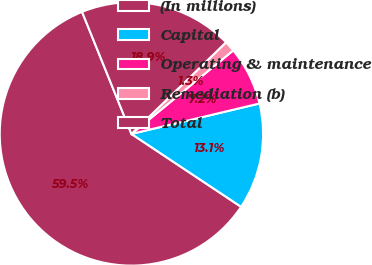Convert chart to OTSL. <chart><loc_0><loc_0><loc_500><loc_500><pie_chart><fcel>(In millions)<fcel>Capital<fcel>Operating & maintenance<fcel>Remediation (b)<fcel>Total<nl><fcel>59.55%<fcel>13.05%<fcel>7.22%<fcel>1.31%<fcel>18.87%<nl></chart> 